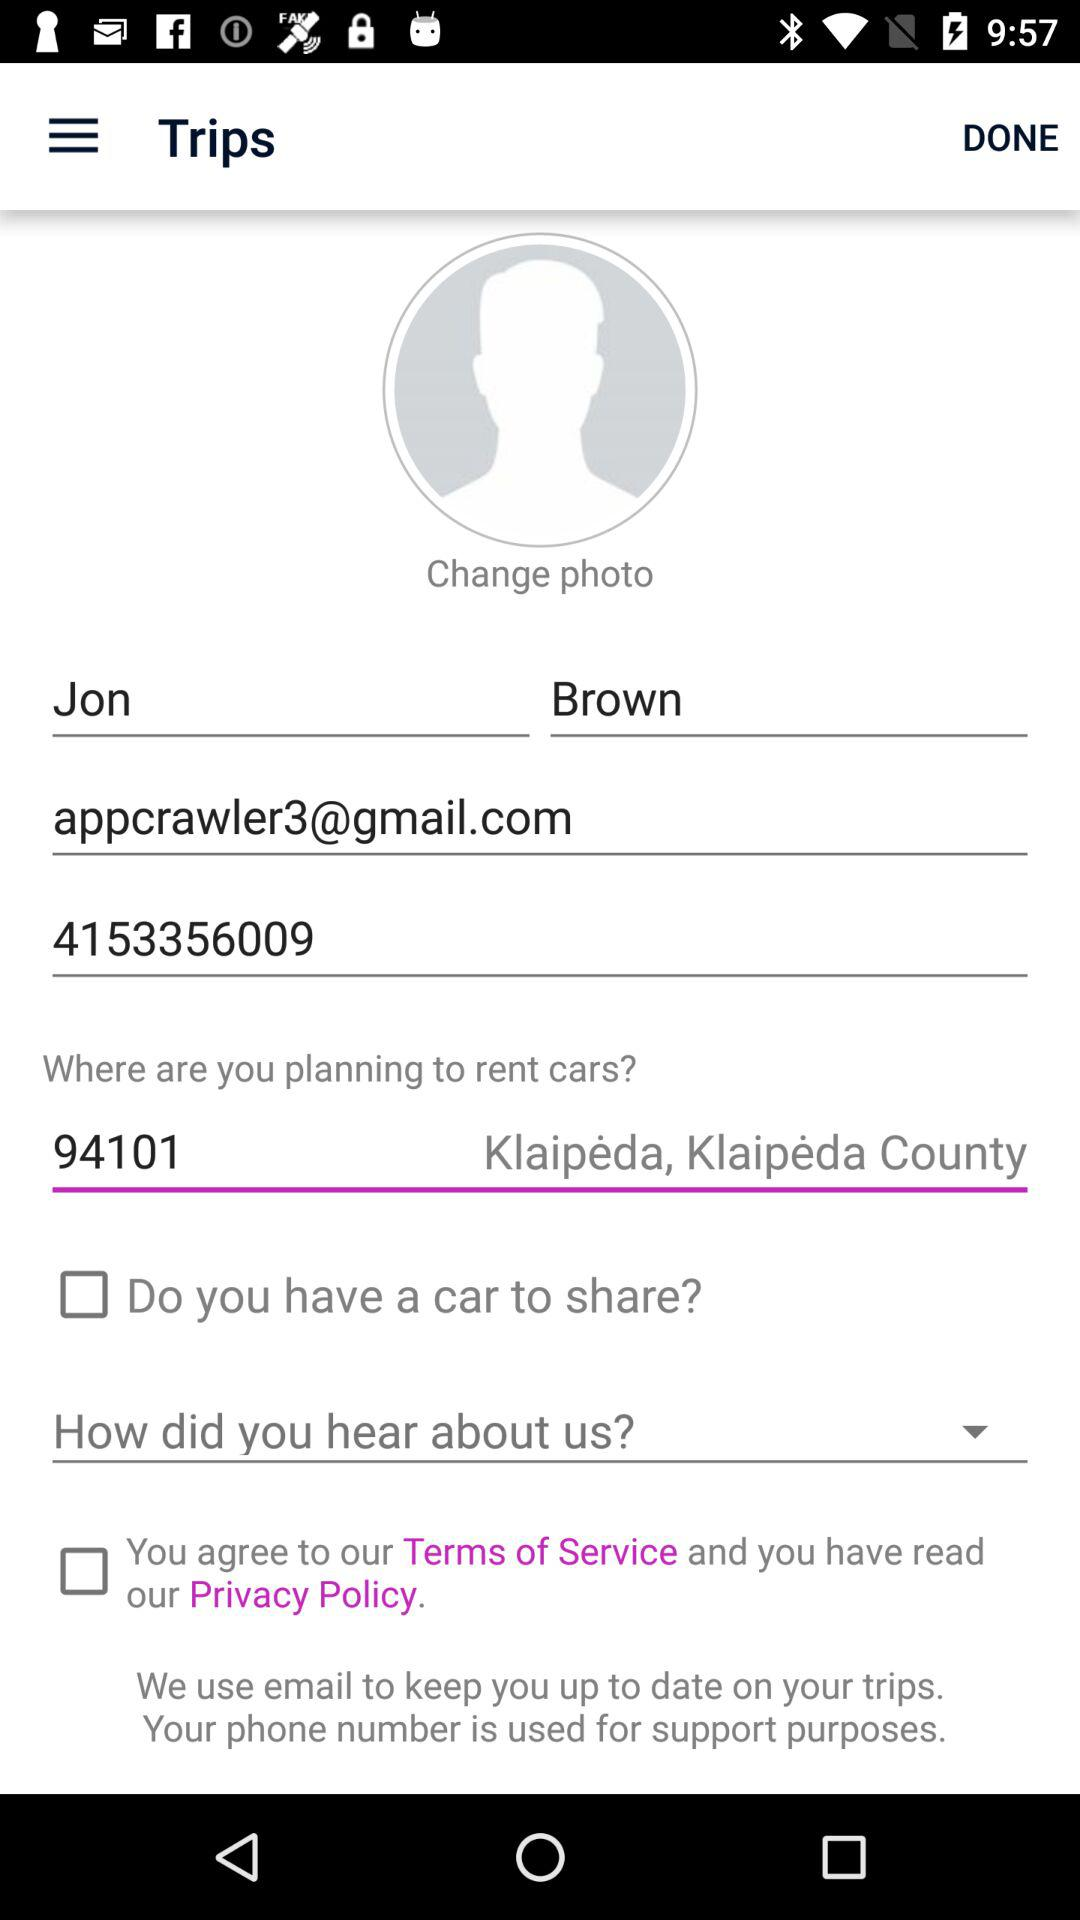What is the name of the user? The name of the user is Jon Brown. 